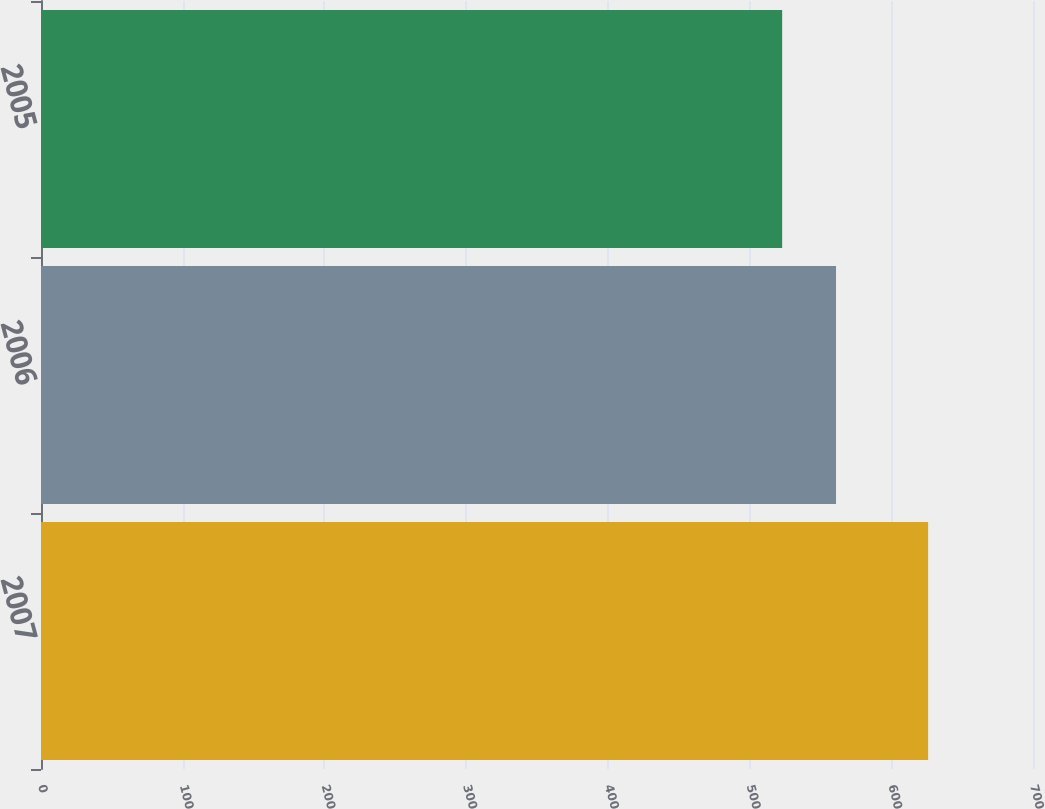Convert chart. <chart><loc_0><loc_0><loc_500><loc_500><bar_chart><fcel>2007<fcel>2006<fcel>2005<nl><fcel>626<fcel>561<fcel>523<nl></chart> 